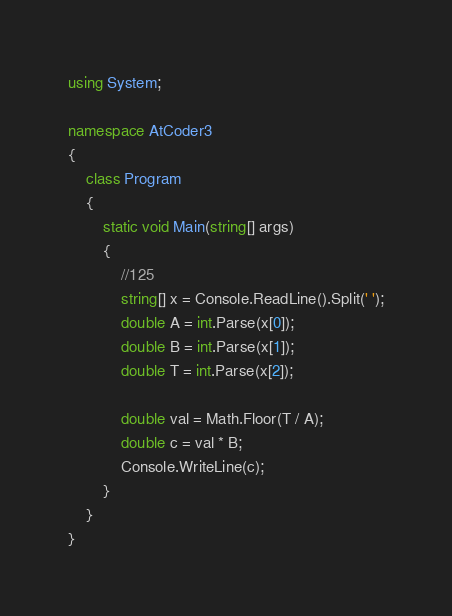Convert code to text. <code><loc_0><loc_0><loc_500><loc_500><_C#_>using System;

namespace AtCoder3
{
    class Program
    {
        static void Main(string[] args)
        {
            //125
            string[] x = Console.ReadLine().Split(' ');
            double A = int.Parse(x[0]);
            double B = int.Parse(x[1]);
            double T = int.Parse(x[2]);

            double val = Math.Floor(T / A);
            double c = val * B;
            Console.WriteLine(c);
        }
    }
}</code> 